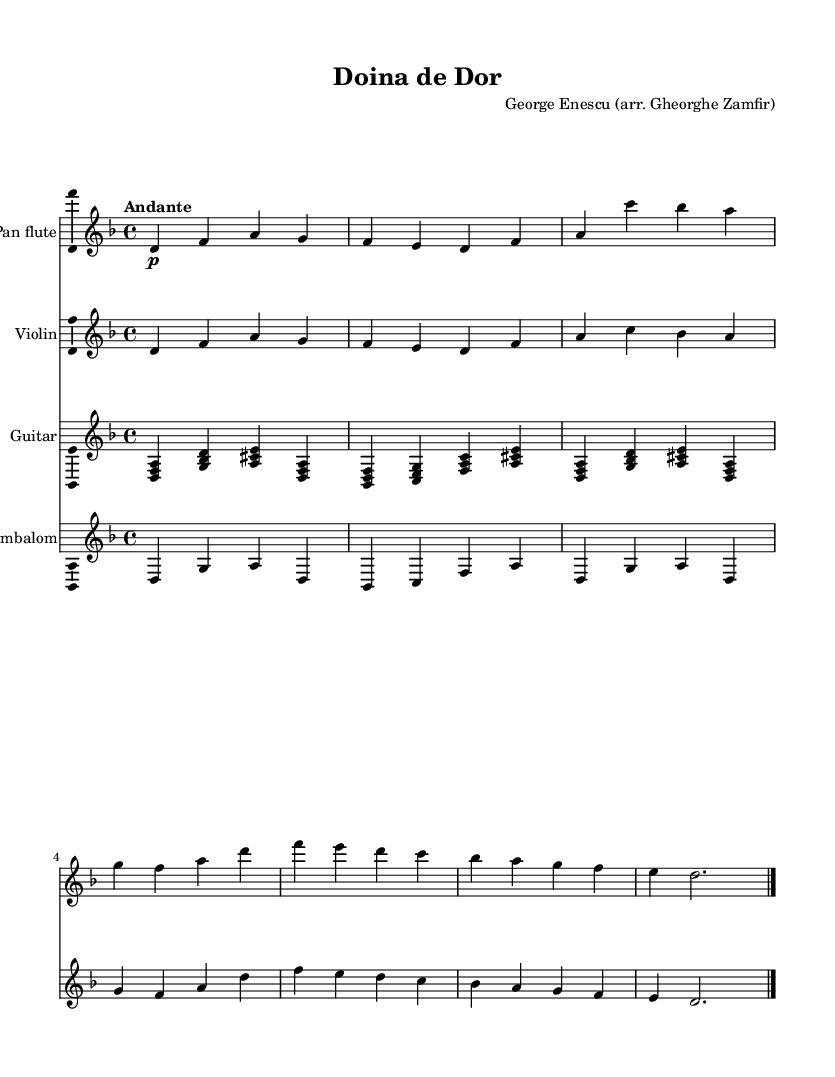What is the key signature of this music? The key signature shows two flats (B♭ and E♭), indicating that the key is D minor.
Answer: D minor What is the time signature of this piece? The time signature is indicated at the beginning of the score, showing 4/4 which means there are four beats per measure.
Answer: 4/4 What is the tempo marking for this piece? The tempo marking is indicated at the start of the music, which is "Andante," suggesting a moderately slow pace.
Answer: Andante How many instruments are present in this score? The score includes four different staves for four instruments: pan flute, violin, guitar, and cimbalom, as seen in the separate parts.
Answer: Four What is the first note played by the pan flute? The first note for the pan flute is indicated at the beginning of its staff and is D, as shown in the first measure.
Answer: D Which instrument plays the harmony with the first note of the melody? The first note of the pan flute is D, which is harmonized by the guitar playing a chord that includes D in the first measure.
Answer: Guitar What type of folk music is "Doina de Dor"? The title indicates that this piece is a type of Romanian folk music, specifically a "doina," which is a traditional genre of Romanian music characterized by its expressive and lyrical qualities.
Answer: Romanian folk music 